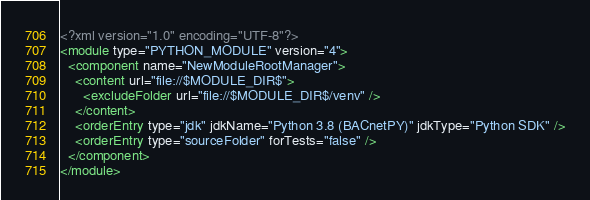Convert code to text. <code><loc_0><loc_0><loc_500><loc_500><_XML_><?xml version="1.0" encoding="UTF-8"?>
<module type="PYTHON_MODULE" version="4">
  <component name="NewModuleRootManager">
    <content url="file://$MODULE_DIR$">
      <excludeFolder url="file://$MODULE_DIR$/venv" />
    </content>
    <orderEntry type="jdk" jdkName="Python 3.8 (BACnetPY)" jdkType="Python SDK" />
    <orderEntry type="sourceFolder" forTests="false" />
  </component>
</module></code> 